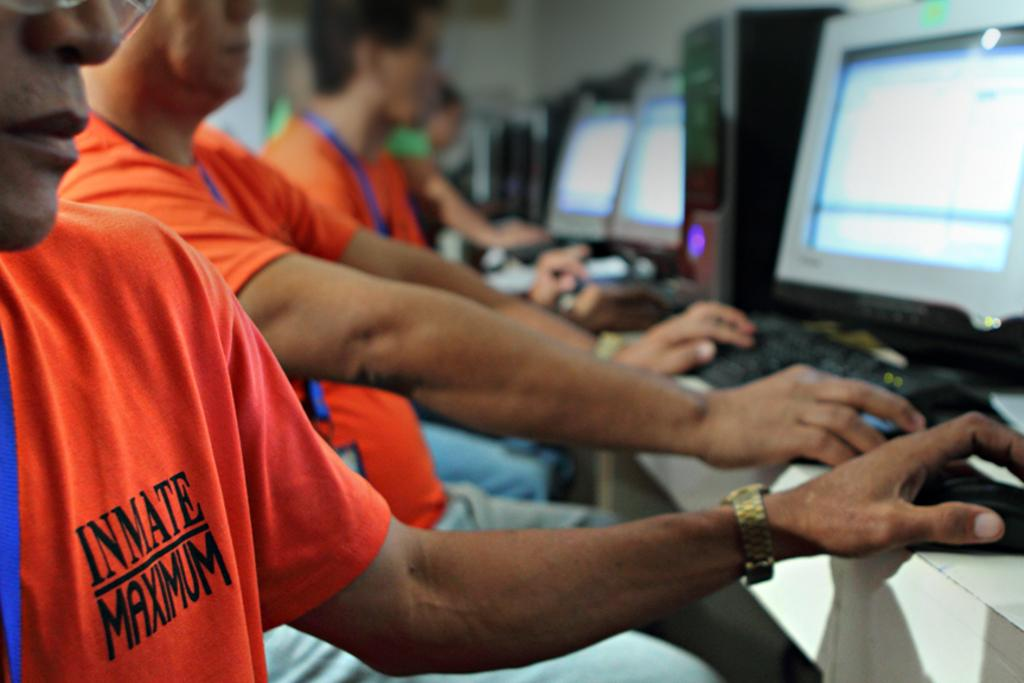<image>
Relay a brief, clear account of the picture shown. The person has clothing on it that says Inmate Maximum 